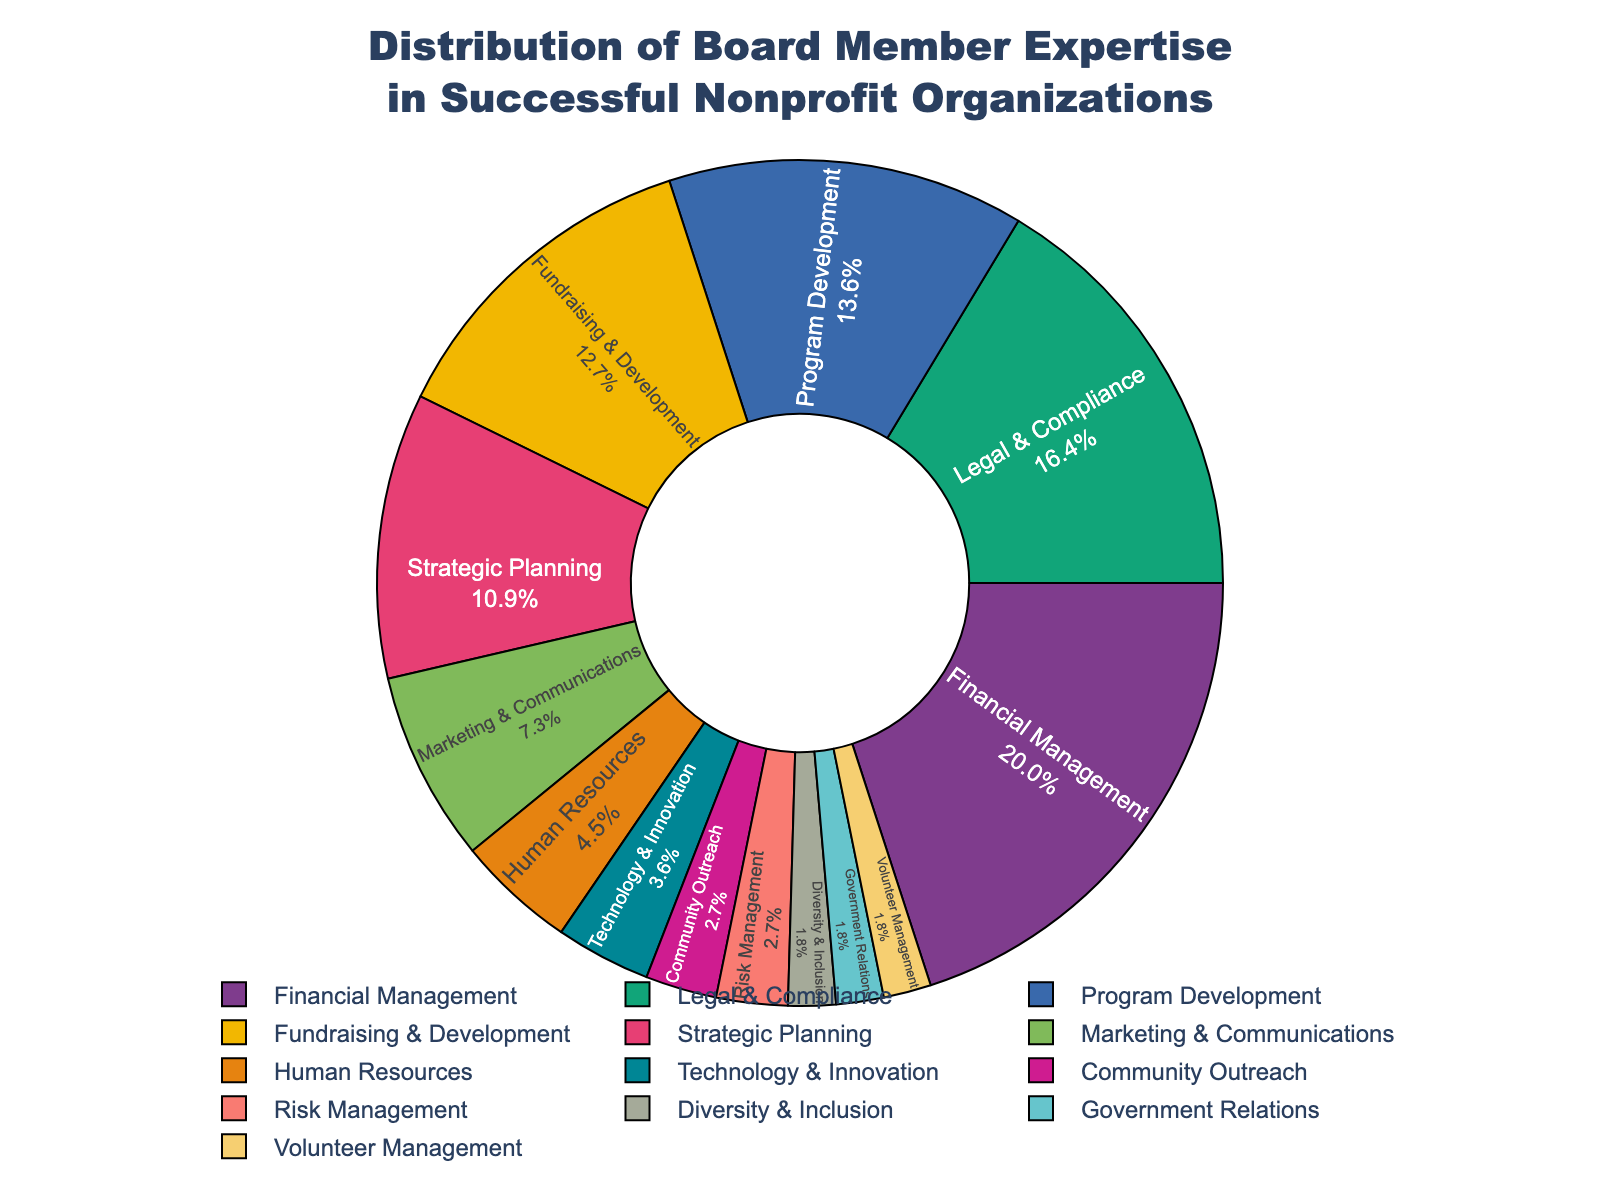What's the sum of the percentages for Marketing & Communications, Human Resources, and Technology & Innovation? Sum the individual percentages of Marketing & Communications (8), Human Resources (5), and Technology & Innovation (4). So, 8 + 5 + 4 = 17.
Answer: 17 Which area of expertise has the highest percentage? Look at the pie chart for the largest segment, which belongs to Financial Management with 22%.
Answer: Financial Management What is the percentage difference between Financial Management and Legal & Compliance? Subtract the percentage of Legal & Compliance (18) from the percentage of Financial Management (22). So, 22 - 18 = 4.
Answer: 4 Are the percentages for Fundraising & Development and Strategic Planning greater than Legal & Compliance combined? Fundraising & Development has 14%, and Strategic Planning has 12%. Combined, they are 14 + 12 = 26, which is greater than Legal & Compliance's 18%.
Answer: Yes Which areas share the smallest percentage, and what is it? The smallest percentages are shared by Diversity & Inclusion, Government Relations, and Volunteer Management, each with 2%.
Answer: Diversity & Inclusion, Government Relations, Volunteer Management What's the combined percentage for Program Development and Community Outreach? Sum the percentages of Program Development (15) and Community Outreach (3). So, 15 + 3 = 18.
Answer: 18 Is the percentage of Legal & Compliance greater than the combined percentages of Technology & Innovation and Community Outreach? Legal & Compliance is 18%. Technology & Innovation (4) and Community Outreach (3) combined equal 4 + 3 = 7, which is less than 18%.
Answer: Yes What is the average percentage of the top three expertise areas? The top three areas are Financial Management (22), Legal & Compliance (18), and Program Development (15). Their average is (22 + 18 + 15) / 3 = 55 / 3 = 18.33.
Answer: 18.33 Is the segment for Strategic Planning larger or smaller than the segment for Fundraising & Development? Strategic Planning has 12% and Fundraising & Development has 14%. The segment for Strategic Planning is smaller than that for Fundraising & Development.
Answer: Smaller What is the ratio of Financial Management to Risk Management in terms of percentage distribution? The percentage for Financial Management is 22% and for Risk Management is 3%. The ratio is 22:3.
Answer: 22:3 